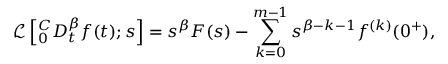Convert formula to latex. <formula><loc_0><loc_0><loc_500><loc_500>\mathcal { L } \left [ ^ { C } _ { 0 } D _ { t } ^ { \beta } f ( t ) ; s \right ] = s ^ { \beta } F ( s ) - \sum _ { k = 0 } ^ { m - 1 } s ^ { \beta - k - 1 } f ^ { ( k ) } ( 0 ^ { + } ) ,</formula> 